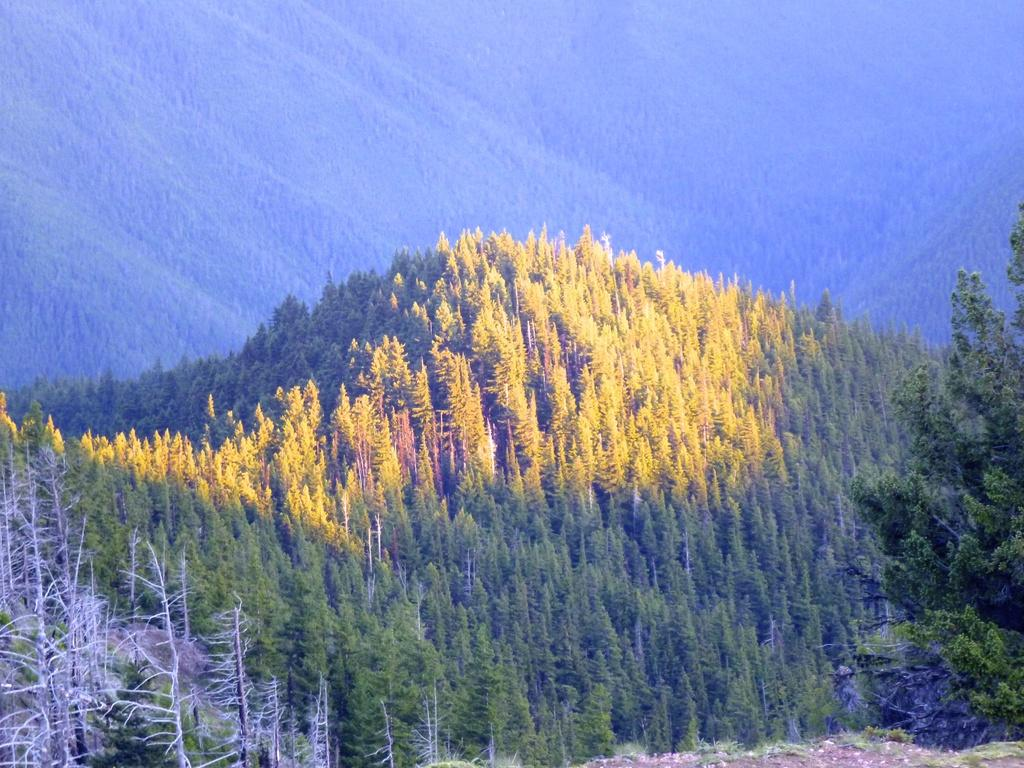What type of vegetation can be seen in the image? There are trees in the image. How would you describe the background of the image? The background of the image is blurred. What type of bread is being used for the voyage in the image? There is no voyage or bread present in the image; it only features trees and a blurred background. 